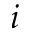<formula> <loc_0><loc_0><loc_500><loc_500>i</formula> 